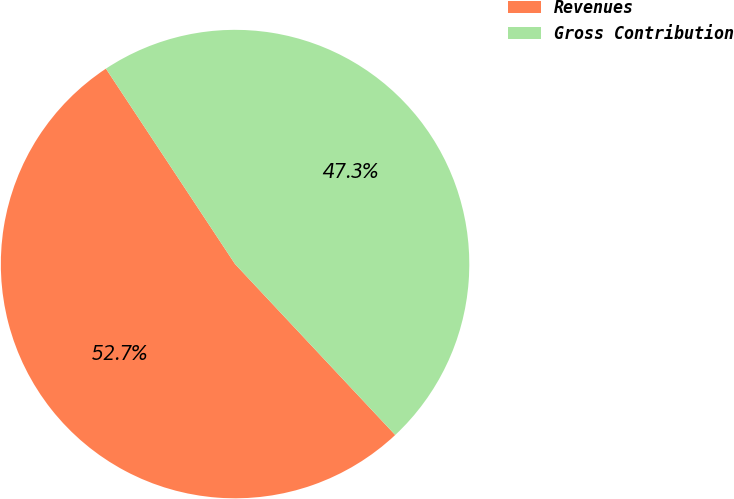<chart> <loc_0><loc_0><loc_500><loc_500><pie_chart><fcel>Revenues<fcel>Gross Contribution<nl><fcel>52.69%<fcel>47.31%<nl></chart> 